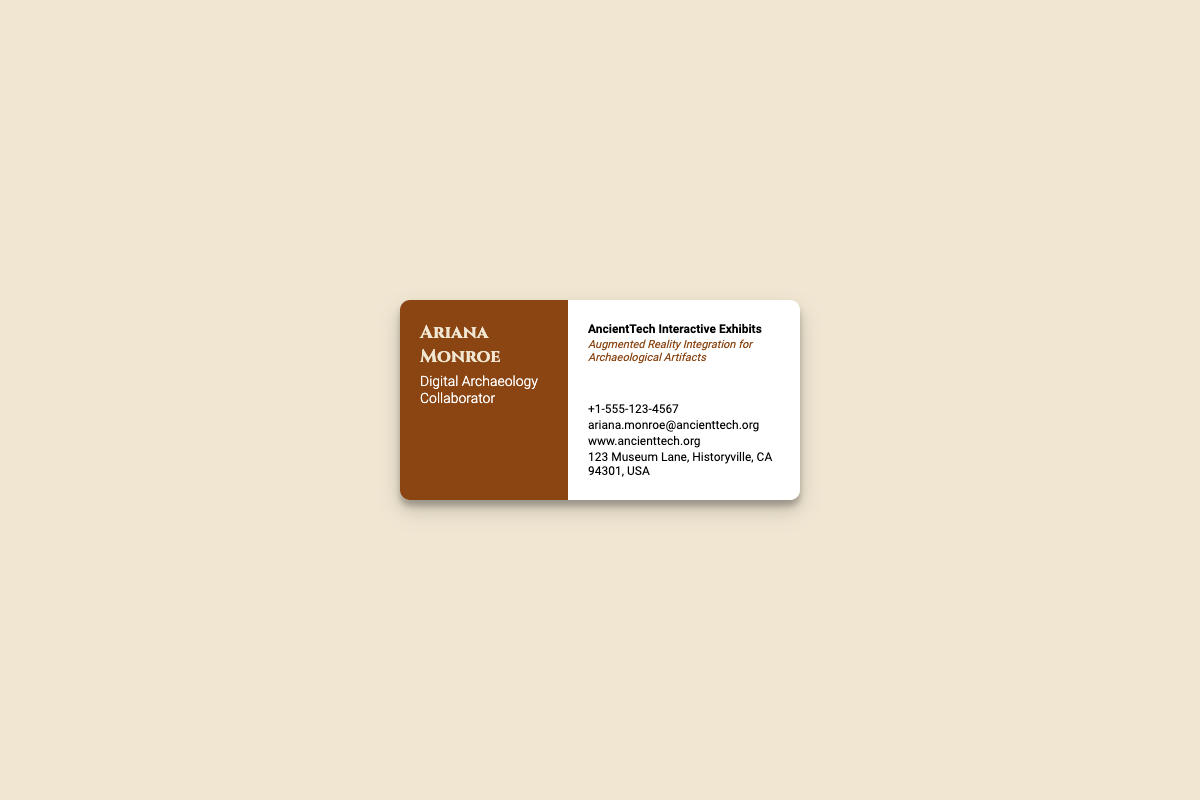What is the name of the collaborator? The name of the collaborator is provided prominently at the top of the card.
Answer: Ariana Monroe What is the phone number listed on the card? The phone number is detailed towards the bottom right of the card adjacent to the phone icon.
Answer: +1-555-123-4567 What is the email address given? The email address is provided next to the envelope icon, which signifies contact information.
Answer: ariana.monroe@ancienttech.org What city is the address located in? The address section of the card lists the complete address, including the city and state.
Answer: Historyville What social media platform is linked to the card? The card features social icons that link to various platforms.
Answer: LinkedIn What is the main specialization highlighted on the card? The specialization is indicated in a smaller italicized font under the main description of the role.
Answer: Augmented Reality Integration for Archaeological Artifacts What type of exhibits is Ariana Monroe associated with? The type of exhibits is described under the icon for augmented reality, indicating the focus of work.
Answer: AncientTech Interactive Exhibits Which icon is used to represent augmented reality? The card includes an icon to symbolize augmented reality, placed next to the title of the exhibits.
Answer: VR Cardboard Icon What is the website provided on the card? The website can be found near the globe icon in the contact section of the card.
Answer: www.ancienttech.org 